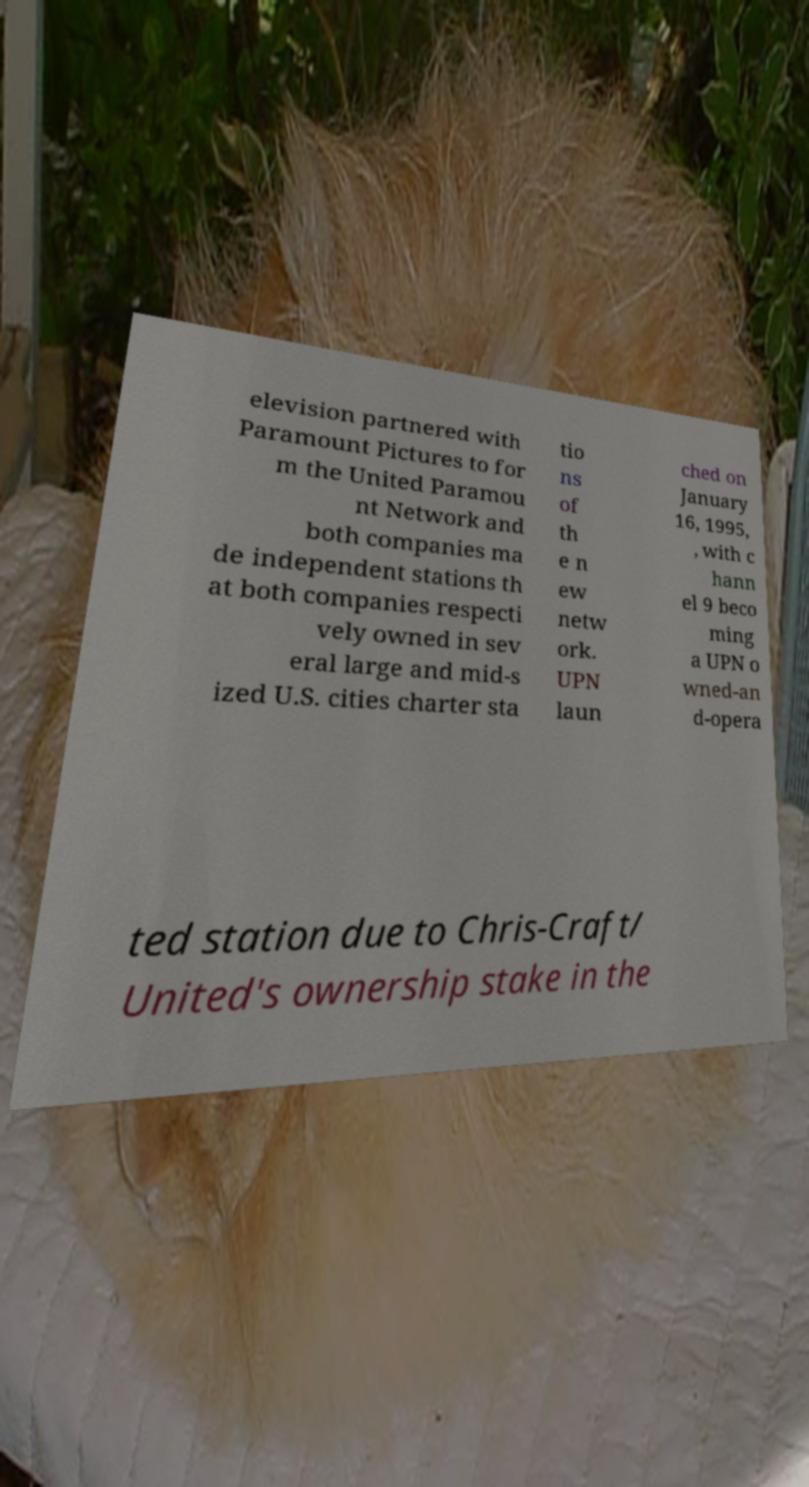For documentation purposes, I need the text within this image transcribed. Could you provide that? elevision partnered with Paramount Pictures to for m the United Paramou nt Network and both companies ma de independent stations th at both companies respecti vely owned in sev eral large and mid-s ized U.S. cities charter sta tio ns of th e n ew netw ork. UPN laun ched on January 16, 1995, , with c hann el 9 beco ming a UPN o wned-an d-opera ted station due to Chris-Craft/ United's ownership stake in the 